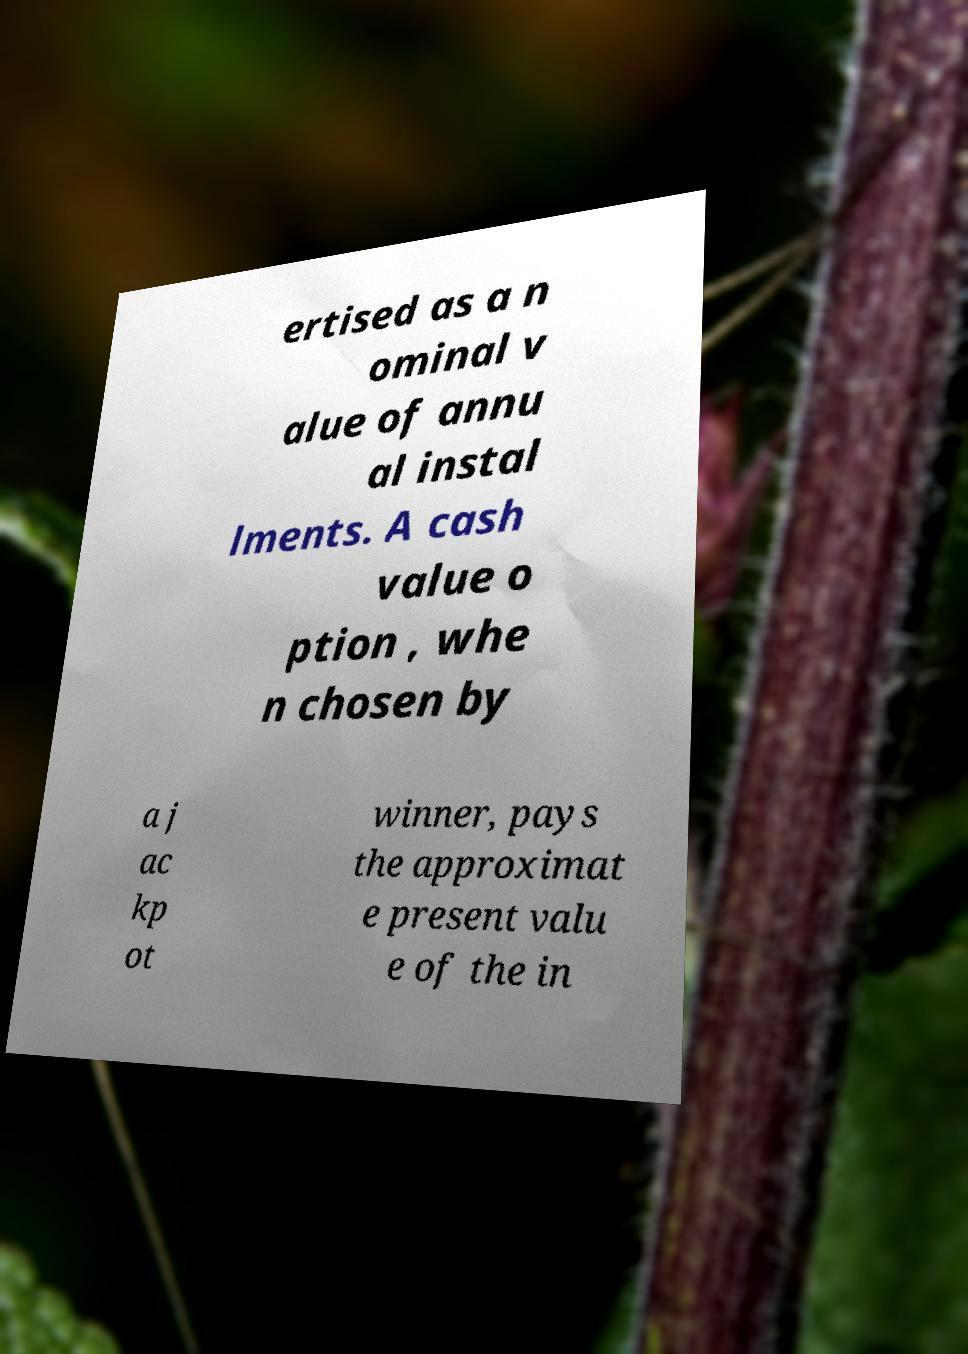I need the written content from this picture converted into text. Can you do that? ertised as a n ominal v alue of annu al instal lments. A cash value o ption , whe n chosen by a j ac kp ot winner, pays the approximat e present valu e of the in 